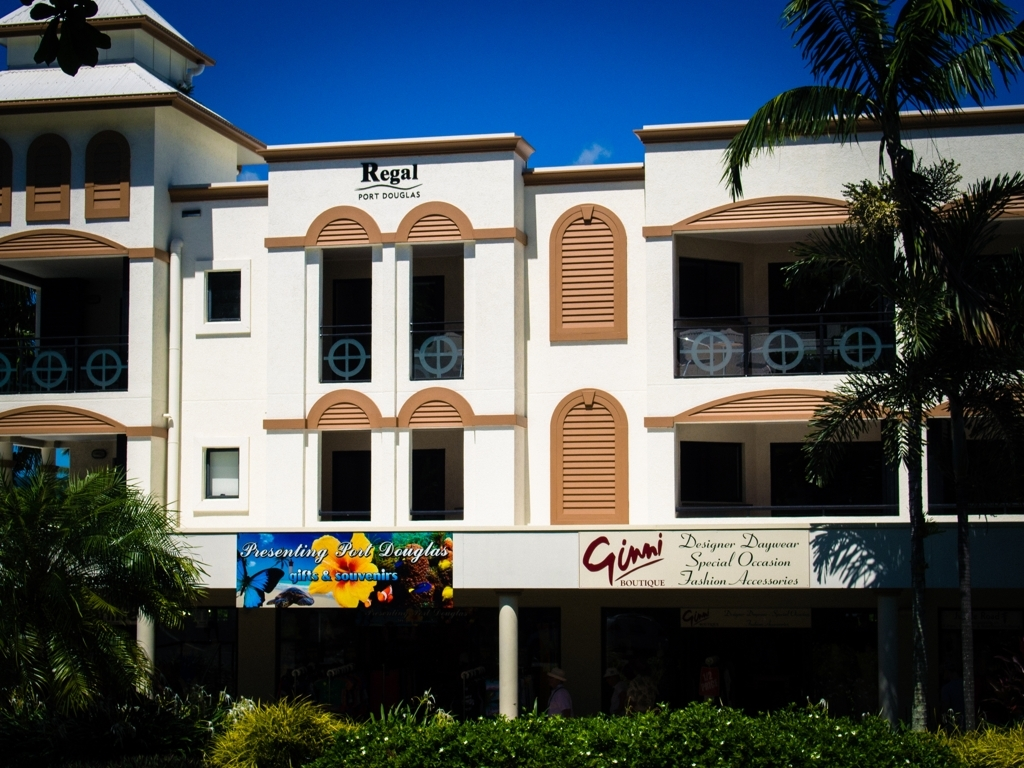Does the image have a high level of detail? The image depicts a building with some architectural elements and signage, but it doesn't present a high level of intricate detail or complexity. There's a clear view of shutters, balconies, and store signs, but there are no fine or elaborate patterns that would imply a higher level of detail. 